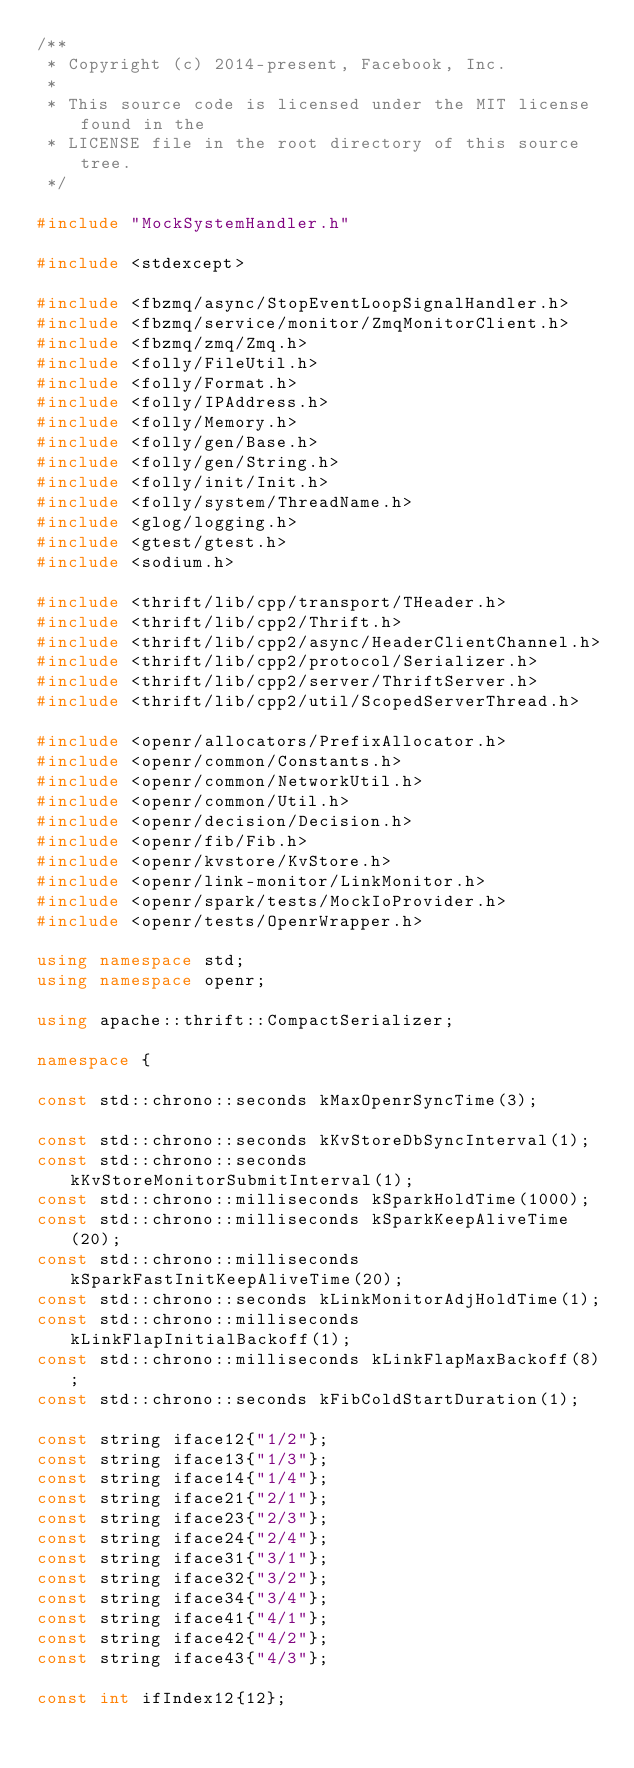Convert code to text. <code><loc_0><loc_0><loc_500><loc_500><_C++_>/**
 * Copyright (c) 2014-present, Facebook, Inc.
 *
 * This source code is licensed under the MIT license found in the
 * LICENSE file in the root directory of this source tree.
 */

#include "MockSystemHandler.h"

#include <stdexcept>

#include <fbzmq/async/StopEventLoopSignalHandler.h>
#include <fbzmq/service/monitor/ZmqMonitorClient.h>
#include <fbzmq/zmq/Zmq.h>
#include <folly/FileUtil.h>
#include <folly/Format.h>
#include <folly/IPAddress.h>
#include <folly/Memory.h>
#include <folly/gen/Base.h>
#include <folly/gen/String.h>
#include <folly/init/Init.h>
#include <folly/system/ThreadName.h>
#include <glog/logging.h>
#include <gtest/gtest.h>
#include <sodium.h>

#include <thrift/lib/cpp/transport/THeader.h>
#include <thrift/lib/cpp2/Thrift.h>
#include <thrift/lib/cpp2/async/HeaderClientChannel.h>
#include <thrift/lib/cpp2/protocol/Serializer.h>
#include <thrift/lib/cpp2/server/ThriftServer.h>
#include <thrift/lib/cpp2/util/ScopedServerThread.h>

#include <openr/allocators/PrefixAllocator.h>
#include <openr/common/Constants.h>
#include <openr/common/NetworkUtil.h>
#include <openr/common/Util.h>
#include <openr/decision/Decision.h>
#include <openr/fib/Fib.h>
#include <openr/kvstore/KvStore.h>
#include <openr/link-monitor/LinkMonitor.h>
#include <openr/spark/tests/MockIoProvider.h>
#include <openr/tests/OpenrWrapper.h>

using namespace std;
using namespace openr;

using apache::thrift::CompactSerializer;

namespace {

const std::chrono::seconds kMaxOpenrSyncTime(3);

const std::chrono::seconds kKvStoreDbSyncInterval(1);
const std::chrono::seconds kKvStoreMonitorSubmitInterval(1);
const std::chrono::milliseconds kSparkHoldTime(1000);
const std::chrono::milliseconds kSparkKeepAliveTime(20);
const std::chrono::milliseconds kSparkFastInitKeepAliveTime(20);
const std::chrono::seconds kLinkMonitorAdjHoldTime(1);
const std::chrono::milliseconds kLinkFlapInitialBackoff(1);
const std::chrono::milliseconds kLinkFlapMaxBackoff(8);
const std::chrono::seconds kFibColdStartDuration(1);

const string iface12{"1/2"};
const string iface13{"1/3"};
const string iface14{"1/4"};
const string iface21{"2/1"};
const string iface23{"2/3"};
const string iface24{"2/4"};
const string iface31{"3/1"};
const string iface32{"3/2"};
const string iface34{"3/4"};
const string iface41{"4/1"};
const string iface42{"4/2"};
const string iface43{"4/3"};

const int ifIndex12{12};</code> 